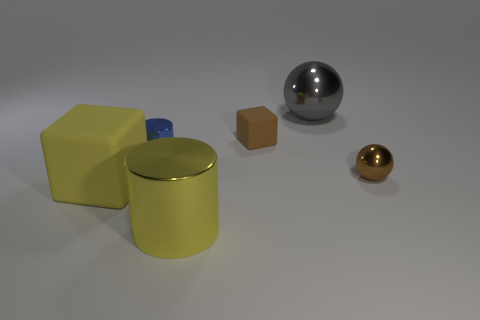Are there any tiny metal objects of the same color as the tiny rubber cube?
Your answer should be very brief. Yes. Does the big cube have the same color as the shiny cylinder that is to the right of the blue cylinder?
Offer a very short reply. Yes. There is a gray thing that is the same material as the small ball; what shape is it?
Make the answer very short. Sphere. Is there another metallic object of the same shape as the big gray object?
Your answer should be compact. Yes. What number of other objects are there of the same shape as the small matte thing?
Make the answer very short. 1. What shape is the small object that is left of the tiny brown sphere and right of the tiny blue shiny cylinder?
Offer a terse response. Cube. There is a sphere that is to the right of the large ball; how big is it?
Ensure brevity in your answer.  Small. Does the yellow matte block have the same size as the gray metal sphere?
Ensure brevity in your answer.  Yes. Are there fewer small metal cylinders that are to the right of the large yellow shiny object than yellow matte cubes that are on the left side of the brown rubber block?
Your response must be concise. Yes. There is a metal object that is both behind the small brown metal ball and on the left side of the large gray ball; what size is it?
Provide a short and direct response. Small. 